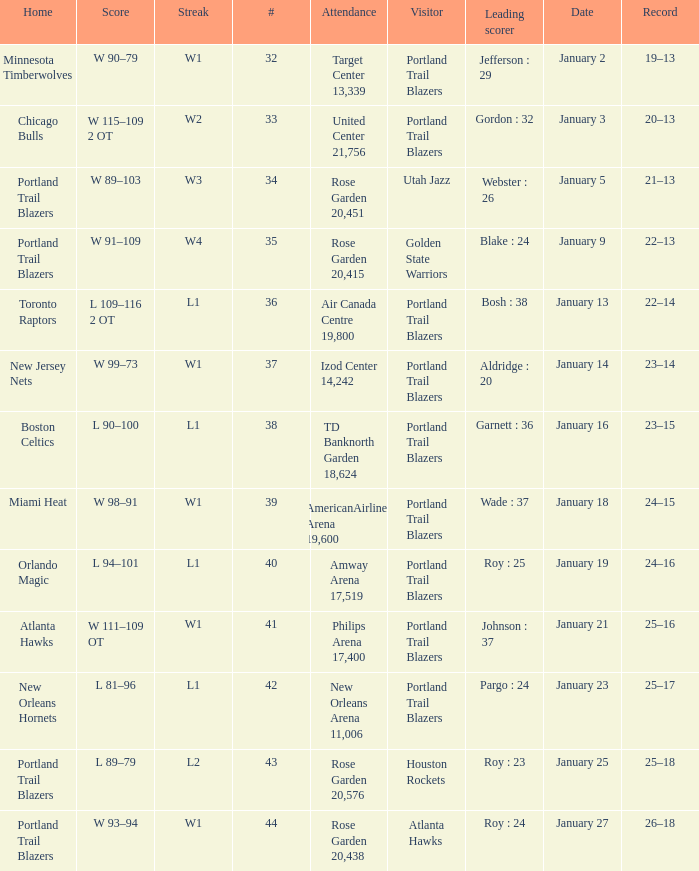What are all the records with a score is w 98–91 24–15. Write the full table. {'header': ['Home', 'Score', 'Streak', '#', 'Attendance', 'Visitor', 'Leading scorer', 'Date', 'Record'], 'rows': [['Minnesota Timberwolves', 'W 90–79', 'W1', '32', 'Target Center 13,339', 'Portland Trail Blazers', 'Jefferson : 29', 'January 2', '19–13'], ['Chicago Bulls', 'W 115–109 2 OT', 'W2', '33', 'United Center 21,756', 'Portland Trail Blazers', 'Gordon : 32', 'January 3', '20–13'], ['Portland Trail Blazers', 'W 89–103', 'W3', '34', 'Rose Garden 20,451', 'Utah Jazz', 'Webster : 26', 'January 5', '21–13'], ['Portland Trail Blazers', 'W 91–109', 'W4', '35', 'Rose Garden 20,415', 'Golden State Warriors', 'Blake : 24', 'January 9', '22–13'], ['Toronto Raptors', 'L 109–116 2 OT', 'L1', '36', 'Air Canada Centre 19,800', 'Portland Trail Blazers', 'Bosh : 38', 'January 13', '22–14'], ['New Jersey Nets', 'W 99–73', 'W1', '37', 'Izod Center 14,242', 'Portland Trail Blazers', 'Aldridge : 20', 'January 14', '23–14'], ['Boston Celtics', 'L 90–100', 'L1', '38', 'TD Banknorth Garden 18,624', 'Portland Trail Blazers', 'Garnett : 36', 'January 16', '23–15'], ['Miami Heat', 'W 98–91', 'W1', '39', 'AmericanAirlines Arena 19,600', 'Portland Trail Blazers', 'Wade : 37', 'January 18', '24–15'], ['Orlando Magic', 'L 94–101', 'L1', '40', 'Amway Arena 17,519', 'Portland Trail Blazers', 'Roy : 25', 'January 19', '24–16'], ['Atlanta Hawks', 'W 111–109 OT', 'W1', '41', 'Philips Arena 17,400', 'Portland Trail Blazers', 'Johnson : 37', 'January 21', '25–16'], ['New Orleans Hornets', 'L 81–96', 'L1', '42', 'New Orleans Arena 11,006', 'Portland Trail Blazers', 'Pargo : 24', 'January 23', '25–17'], ['Portland Trail Blazers', 'L 89–79', 'L2', '43', 'Rose Garden 20,576', 'Houston Rockets', 'Roy : 23', 'January 25', '25–18'], ['Portland Trail Blazers', 'W 93–94', 'W1', '44', 'Rose Garden 20,438', 'Atlanta Hawks', 'Roy : 24', 'January 27', '26–18']]} 